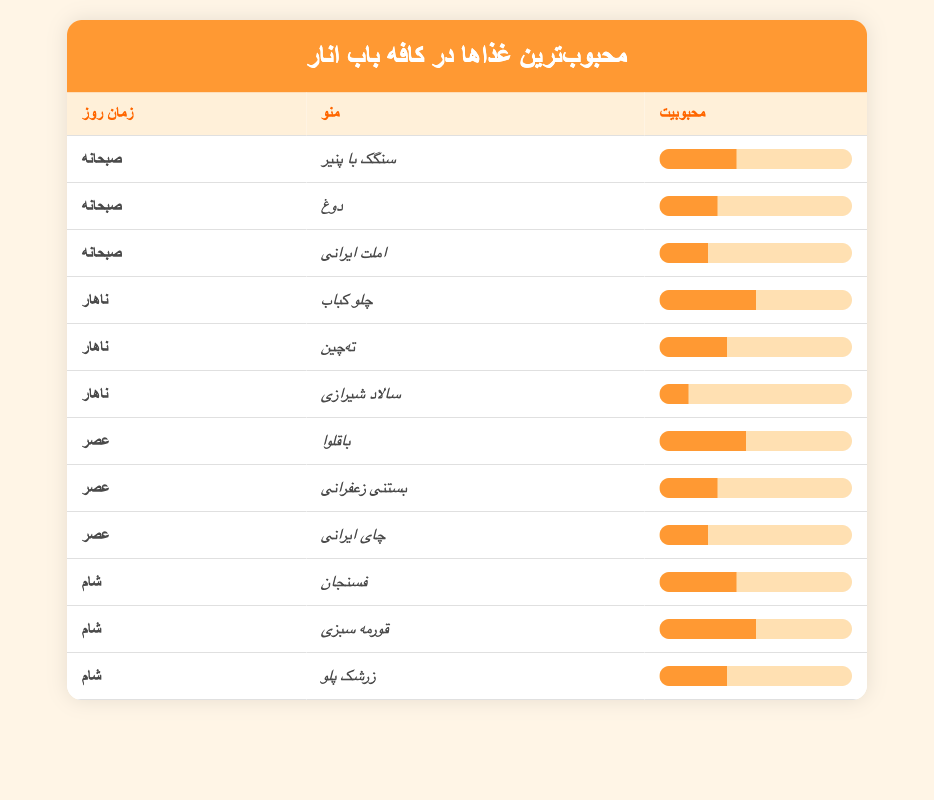What is the most popular breakfast item? The most popular breakfast item is "Sangak with Cheese" with a popularity score of 40. This can be directly observed in the breakfast section of the table, where the items and their popularity are listed.
Answer: Sangak with Cheese How many lunch menu items have a popularity score of 30 or higher? In the lunch section of the table, there are three items with popularity scores of 30 or higher: "Chelo Kebab" (50), "Tahchin" (35), and "Salad Shirazi" (15). Therefore, the count of items meeting the criterion is three.
Answer: 2 Is "Baklava" more popular than "Saffron Ice Cream"? "Baklava" has a popularity score of 45, while "Saffron Ice Cream" has a score of 30. Since 45 is greater than 30, we can affirm that "Baklava" is indeed more popular than "Saffron Ice Cream".
Answer: Yes Which dinner item has the highest popularity score? From the dinner section, "Ghormeh Sabzi" has the highest popularity score of 50. This is identified by comparing the scores of "Fesenjan" (40), "Ghormeh Sabzi" (50), and "Zereshk Polo" (35). Among these, Ghormeh Sabzi stands out.
Answer: Ghormeh Sabzi What is the average popularity of all lunch items? The lunch items are "Chelo Kebab" (50), "Tahchin" (35), and "Salad Shirazi" (15). To calculate the average, sum these scores: 50 + 35 + 15 = 100. Then, divide by the number of items, which is 3. So, the average is 100 / 3 = approximately 33.33.
Answer: 33.33 Are there more popular dinner items compared to breakfast items? In the dinner section, the popular items are "Fesenjan" (40), "Ghormeh Sabzi" (50), and "Zereshk Polo" (35), totaling 3 items. In breakfast, there are three items as well: "Sangak with Cheese" (40), "Doogh" (30), and "Persian Omelette" (25). Both sections have the same number of popular items.
Answer: No What is the rank order of lunch items by their popularity? The lunch items ranked by popularity from highest to lowest are: "Chelo Kebab" (50), "Tahchin" (35), and "Salad Shirazi" (15). This can be determined by looking at their respective popularity scores and arranging them in descending order.
Answer: Chelo Kebab, Tahchin, Salad Shirazi 